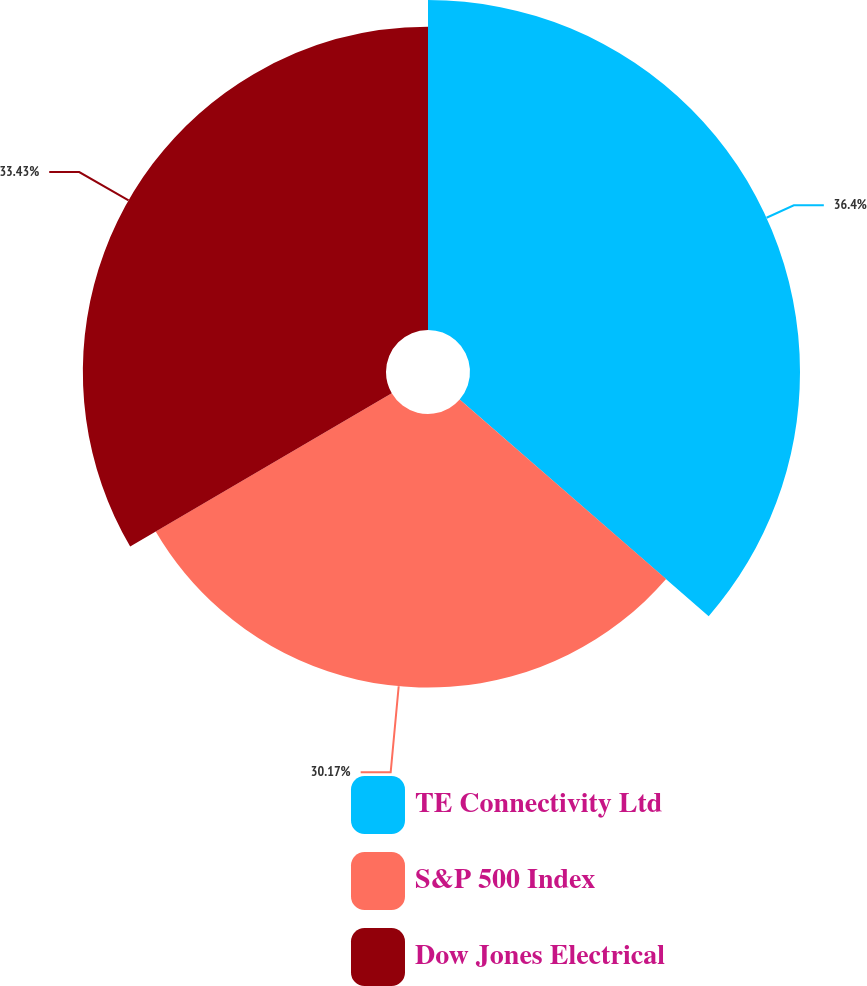Convert chart. <chart><loc_0><loc_0><loc_500><loc_500><pie_chart><fcel>TE Connectivity Ltd<fcel>S&P 500 Index<fcel>Dow Jones Electrical<nl><fcel>36.39%<fcel>30.17%<fcel>33.43%<nl></chart> 